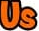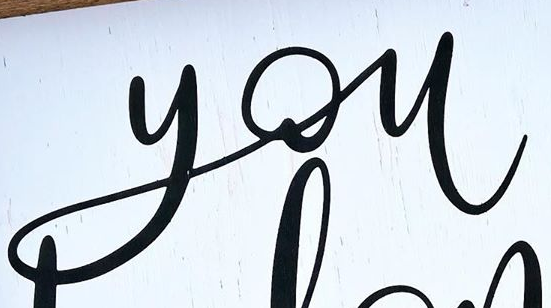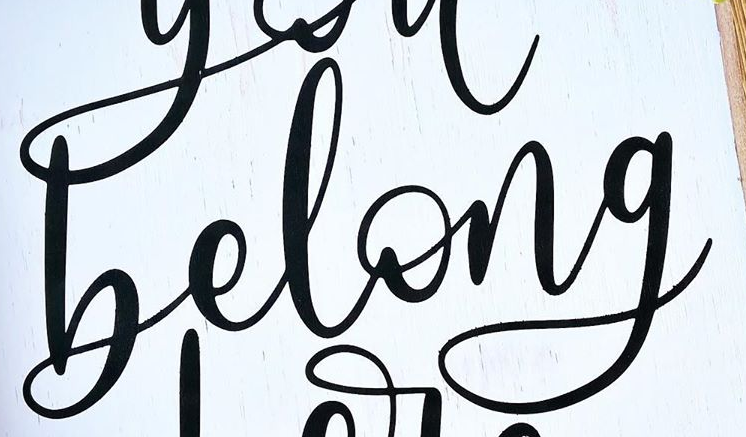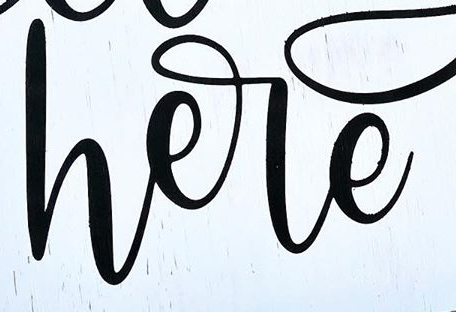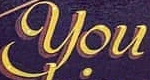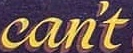What text is displayed in these images sequentially, separated by a semicolon? Us; you; belong; here; You; can't 